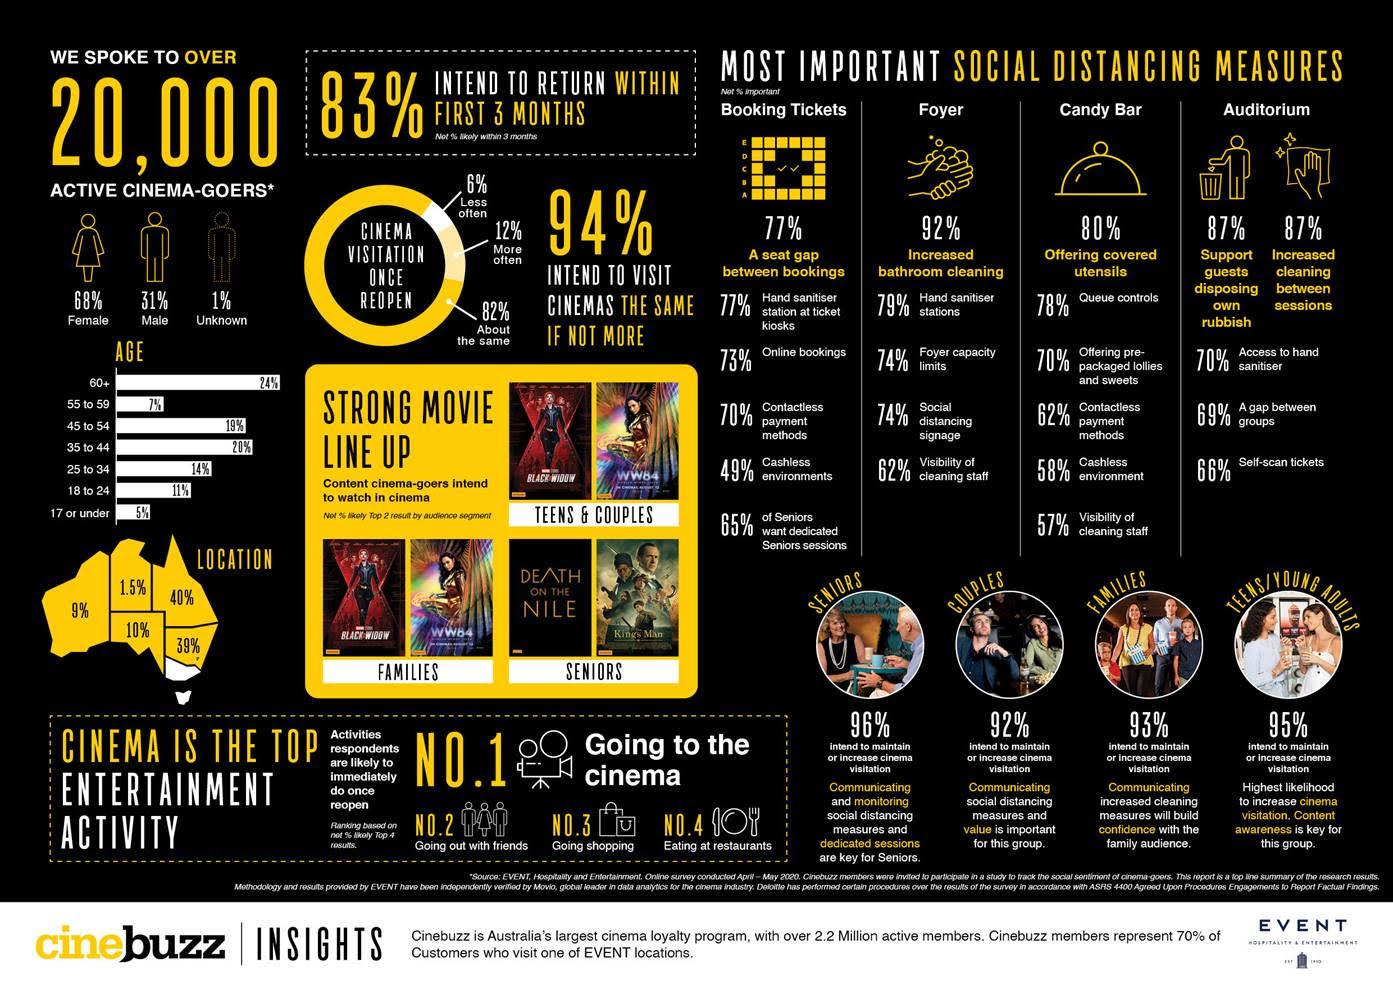Point out several critical features in this image. According to Cinebuzz insights, the age group that has the highest percentage of cinema-goers is 60 years old and above. Of the 20,000 active cinema-goers, 68% constitute females. Out of the total number of 20,000 active cinema-goers, 31% are male. According to Cinebuzz insights, 12% of people intend to visit cinemas more often. Once the activities are reopened, according to the respondents, the top number three entertainment activity is going shopping. 